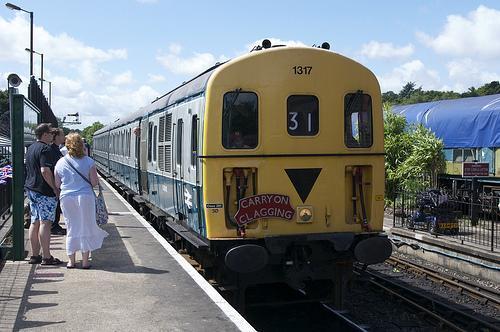How many white skirts?
Give a very brief answer. 1. 